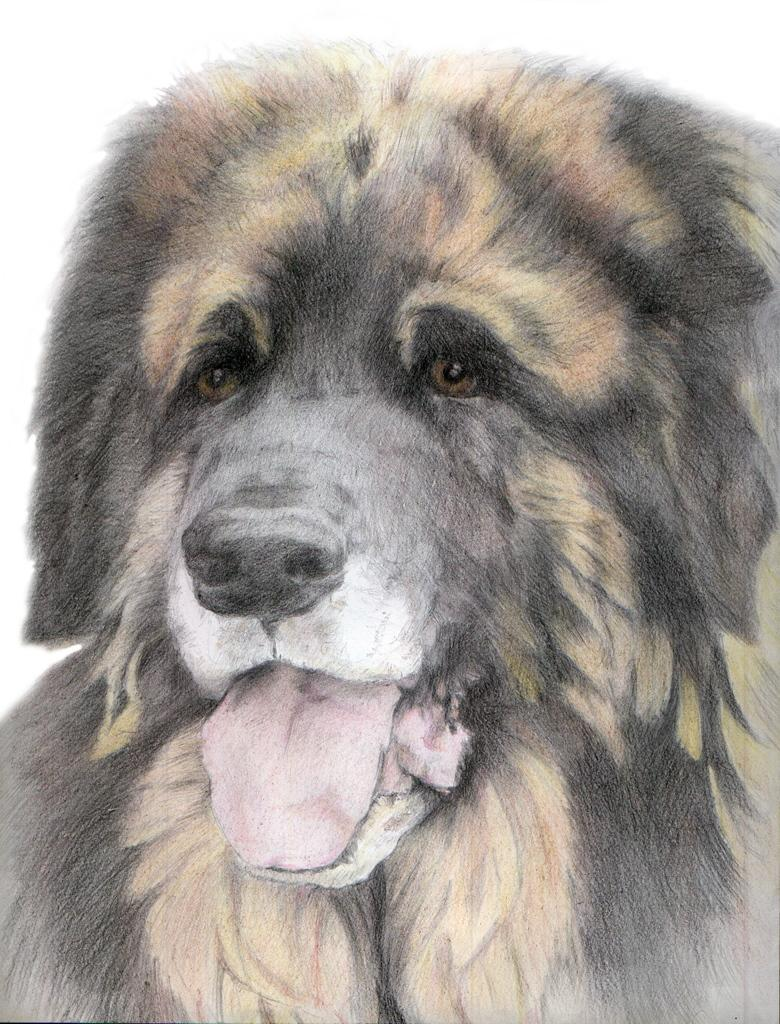What is the main subject of the image? There is a dog in the center of the image. Can you describe the position of the dog in the image? The dog is in the center of the image. What type of animal is featured in the image? The animal featured in the image is a dog. What type of coat is the dog wearing in the image? The dog is not wearing a coat in the image; it is a regular dog without any clothing. 